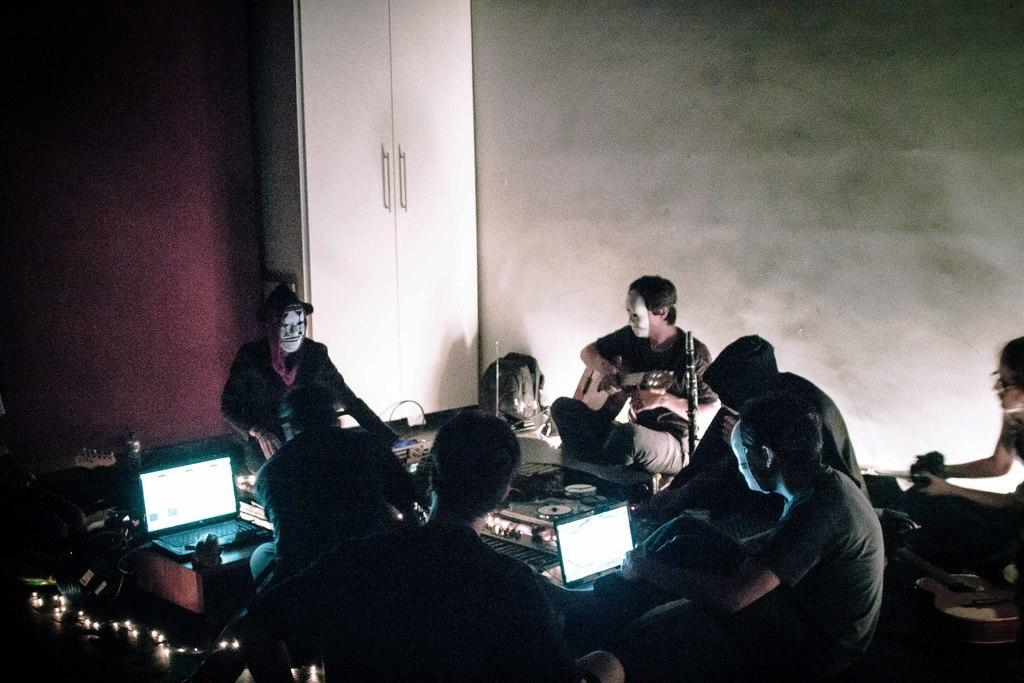What are the people in the image doing? There is a group of people sitting on the floor in the image. What object is in front of the group? There is a laptop in front of the group. Can you describe any other objects present in the image? There are other objects present in the image, but their specific details are not mentioned in the provided facts. What can be seen behind the group? There is a wall visible in the image. What word is being used to stick the people together in the image? There is no indication in the image that the people are being stuck together, nor is there any mention of a word being used for this purpose. 